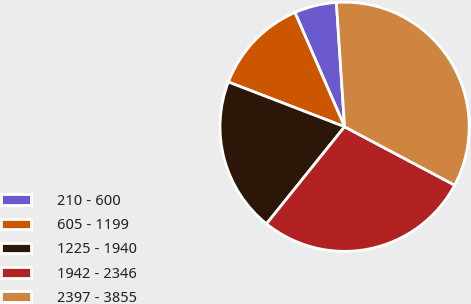Convert chart. <chart><loc_0><loc_0><loc_500><loc_500><pie_chart><fcel>210 - 600<fcel>605 - 1199<fcel>1225 - 1940<fcel>1942 - 2346<fcel>2397 - 3855<nl><fcel>5.48%<fcel>12.62%<fcel>20.07%<fcel>28.02%<fcel>33.81%<nl></chart> 